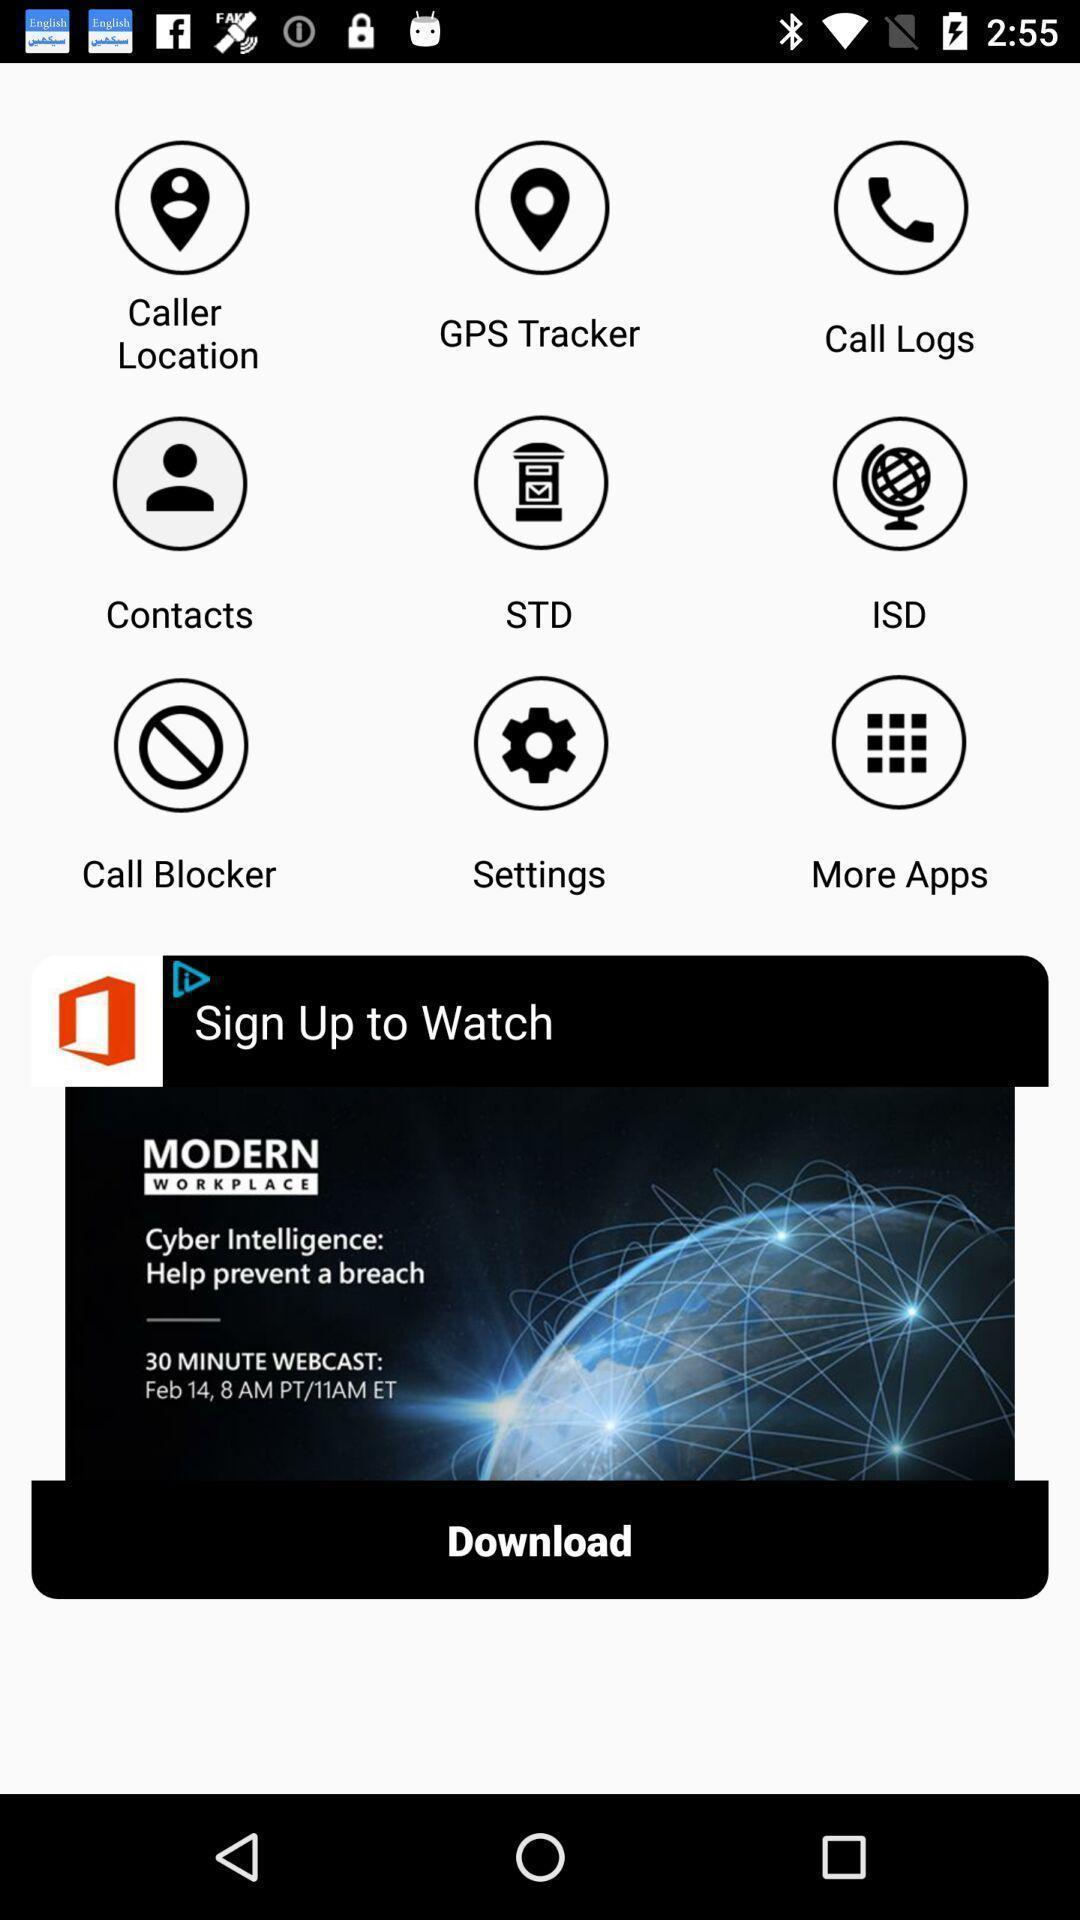Summarize the main components in this picture. Screen displaying the various features and advertisement. 